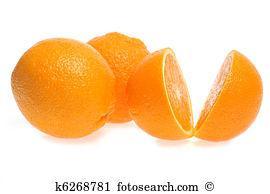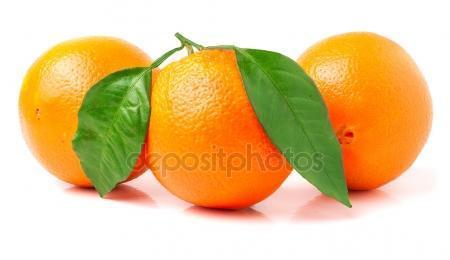The first image is the image on the left, the second image is the image on the right. Considering the images on both sides, is "The right image includes green leaves with three whole oranges, and one image includes two cut orange parts." valid? Answer yes or no. Yes. The first image is the image on the left, the second image is the image on the right. Examine the images to the left and right. Is the description "One photo has greenery and one photo has an orange that is cut, and all photos have at least three oranges." accurate? Answer yes or no. Yes. 